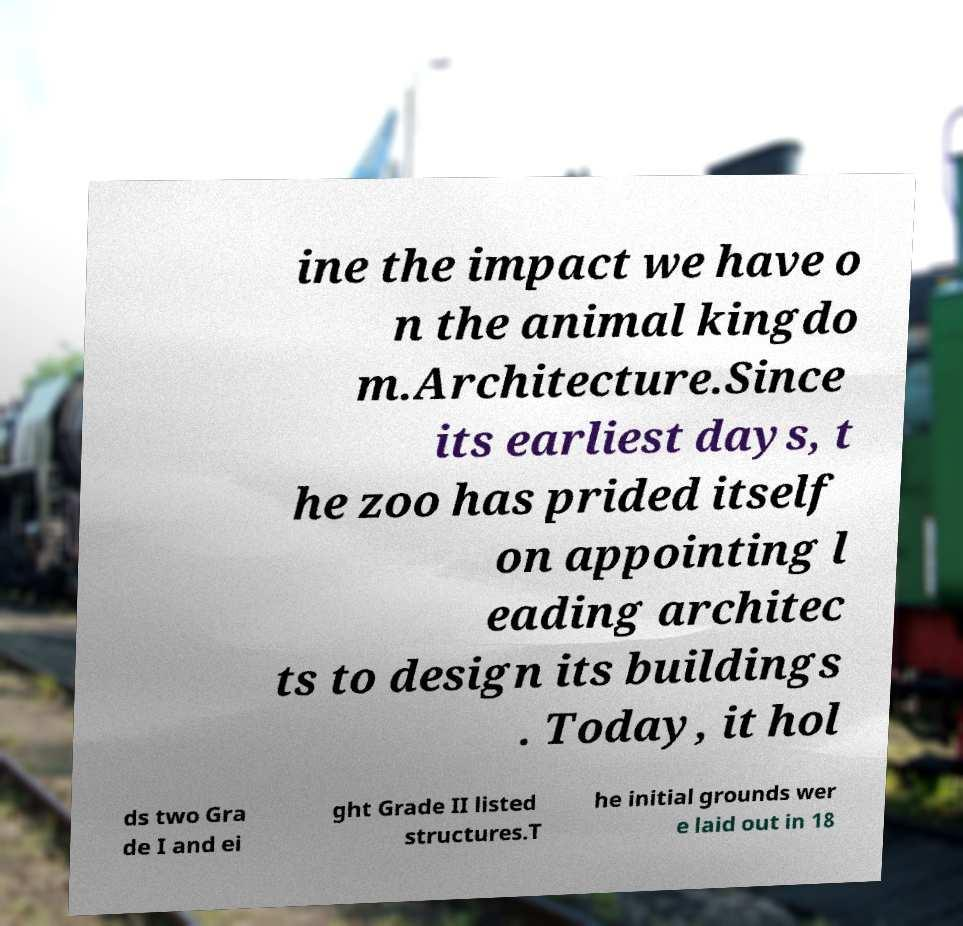Could you assist in decoding the text presented in this image and type it out clearly? ine the impact we have o n the animal kingdo m.Architecture.Since its earliest days, t he zoo has prided itself on appointing l eading architec ts to design its buildings . Today, it hol ds two Gra de I and ei ght Grade II listed structures.T he initial grounds wer e laid out in 18 